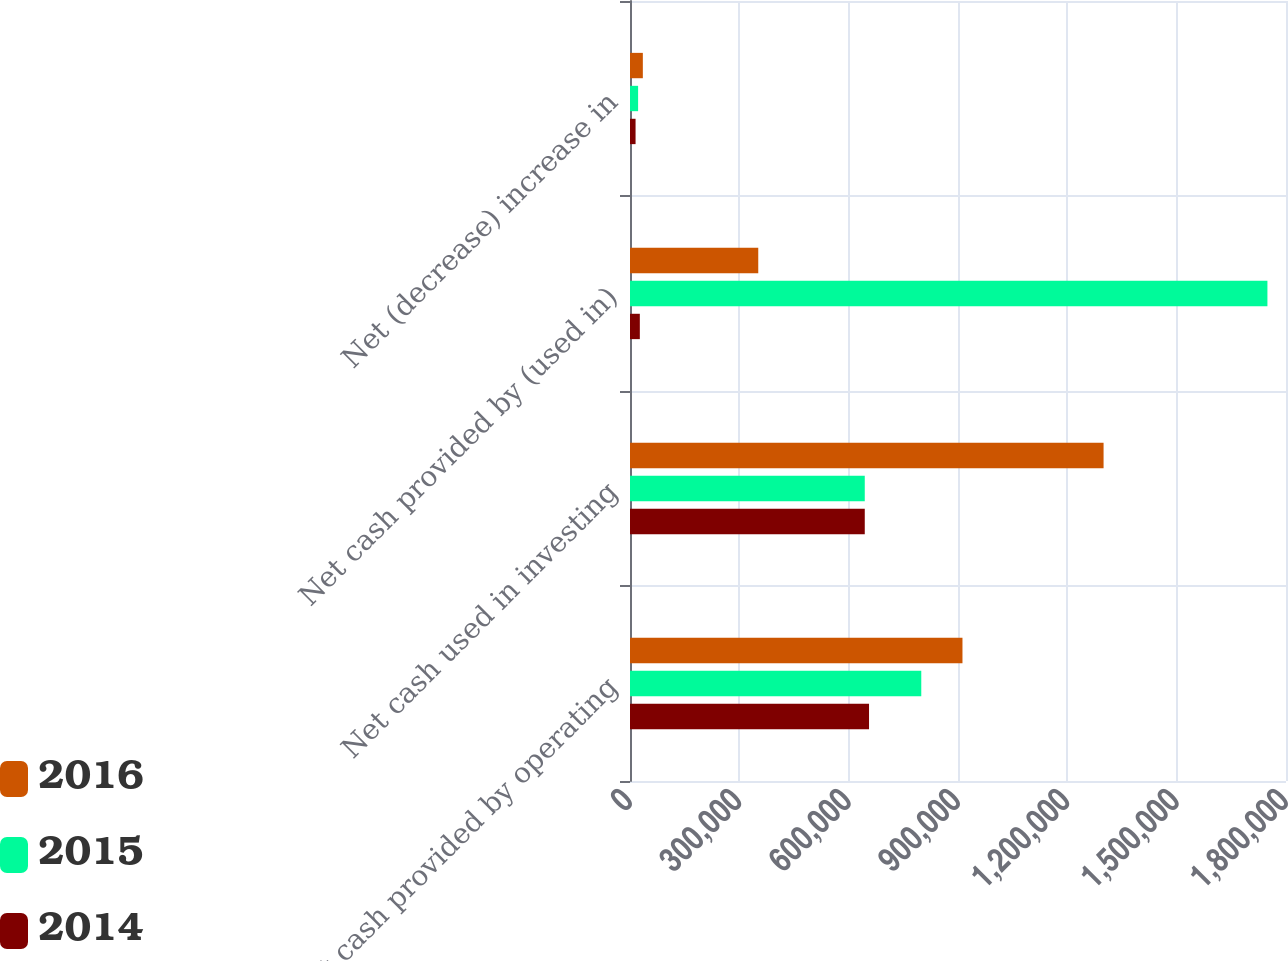Convert chart. <chart><loc_0><loc_0><loc_500><loc_500><stacked_bar_chart><ecel><fcel>Net cash provided by operating<fcel>Net cash used in investing<fcel>Net cash provided by (used in)<fcel>Net (decrease) increase in<nl><fcel>2016<fcel>912262<fcel>1.29943e+06<fcel>351931<fcel>35238<nl><fcel>2015<fcel>799232<fcel>644180<fcel>1.74903e+06<fcel>22239<nl><fcel>2014<fcel>655888<fcel>644180<fcel>26974<fcel>15266<nl></chart> 